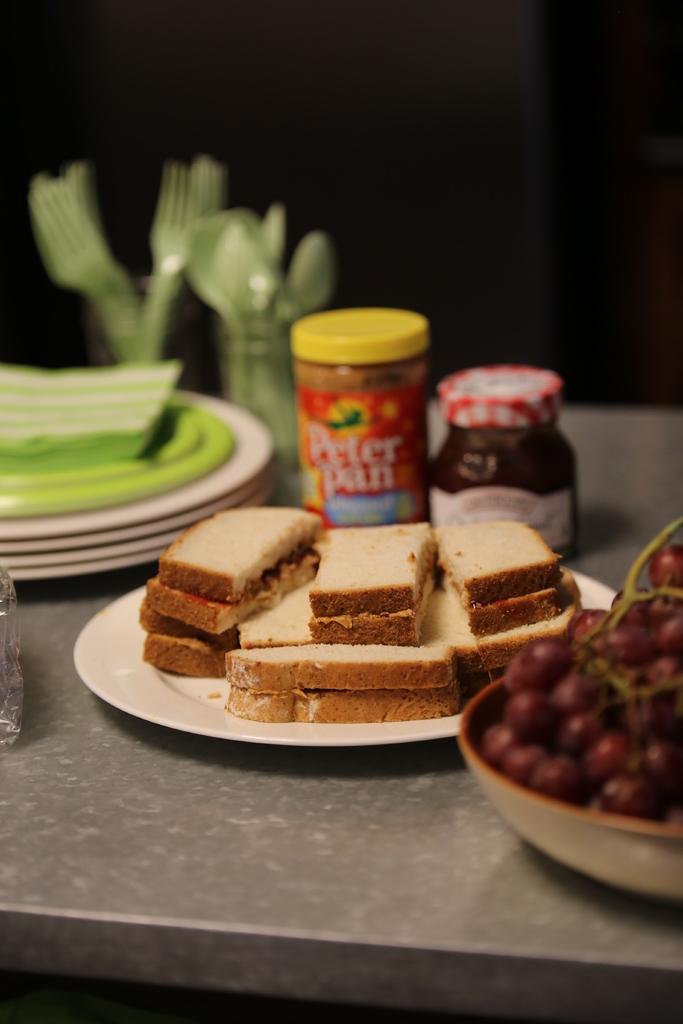Please provide a concise description of this image. This image is taken indoors. In this image the background is dark. At the bottom of the image there is a table with a plate of toasts, a bowl with fruits, a few plates, spoons, forks and two bottles of jam on it. 